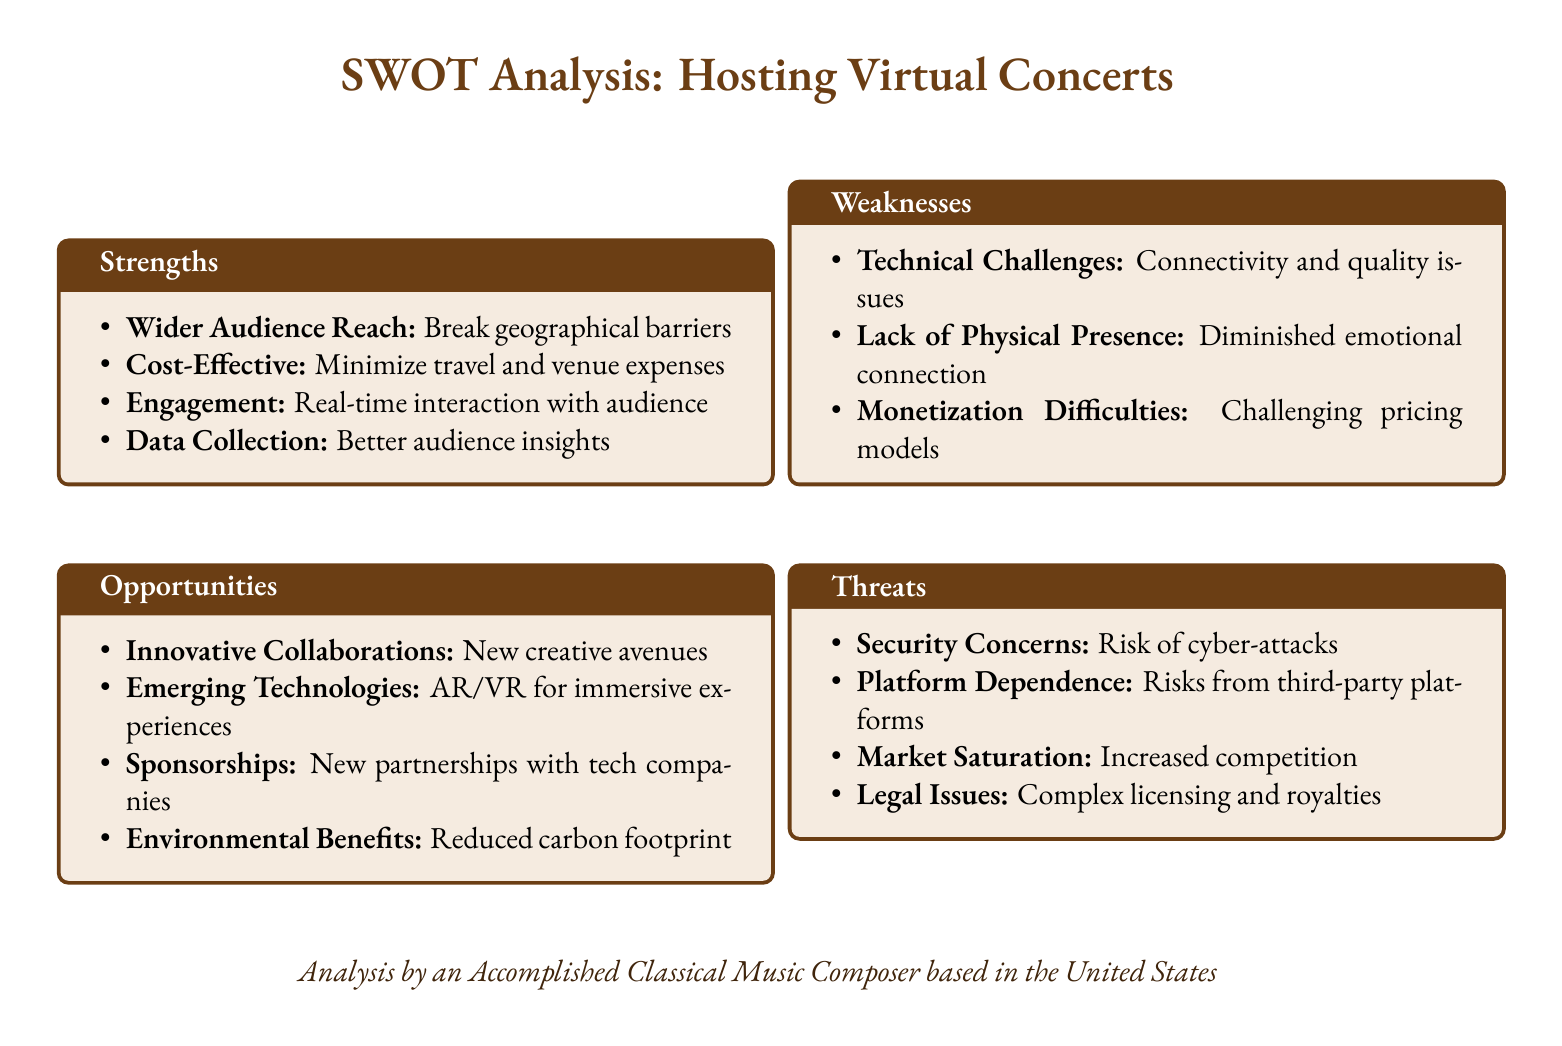What is one strength of hosting virtual concerts? The strength focuses on advantages such as breaking geographical barriers, which leads to wider audience reach.
Answer: Wider Audience Reach What environmental benefit is associated with virtual concerts? The document lists a specific benefit related to the environment, which is a reduced carbon footprint.
Answer: Reduced carbon footprint What is a potential technical challenge mentioned? The weakness section identifies issues like connectivity that can affect virtual concerts.
Answer: Connectivity What innovative opportunity is highlighted in the document? The document discusses new creative avenues emerging from collaborations as a potential opportunity.
Answer: Innovative Collaborations How many weaknesses are listed in the SWOT analysis? The weakness section includes three distinct items, indicating the challenges faced.
Answer: Three What is a threat related to digital security mentioned? The document points out risks associated with cyber-attacks as a security concern.
Answer: Cyber-attacks What aspect of interaction is emphasized as a strength? The analysis mentions real-time interaction with the audience as a significant engagement feature of virtual concerts.
Answer: Engagement What could be a result of market saturation for virtual concerts? The document implies increased competition as a consequence of market saturation, which affects all players involved.
Answer: Increased competition What is a major consideration for monetization of virtual concerts? The difficulties in establishing pricing models present a significant challenge in monetization efforts.
Answer: Challenging pricing models 